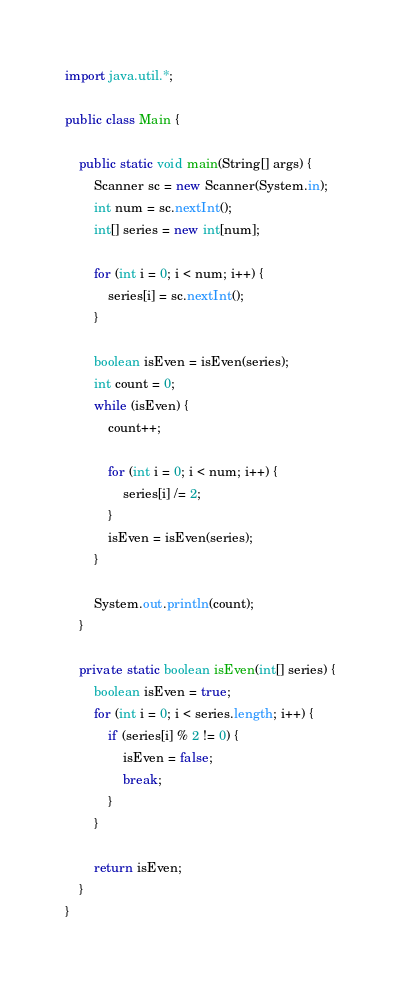Convert code to text. <code><loc_0><loc_0><loc_500><loc_500><_Java_>import java.util.*;

public class Main {

    public static void main(String[] args) {
        Scanner sc = new Scanner(System.in);
        int num = sc.nextInt();
        int[] series = new int[num];

        for (int i = 0; i < num; i++) {
            series[i] = sc.nextInt();
        }

        boolean isEven = isEven(series);
        int count = 0;
        while (isEven) {
            count++;

            for (int i = 0; i < num; i++) {
                series[i] /= 2;
            }
            isEven = isEven(series);
        }

        System.out.println(count);
    }

    private static boolean isEven(int[] series) {
        boolean isEven = true;
        for (int i = 0; i < series.length; i++) {
            if (series[i] % 2 != 0) {
                isEven = false;
                break;
            }
        }

        return isEven;
    }
}
</code> 